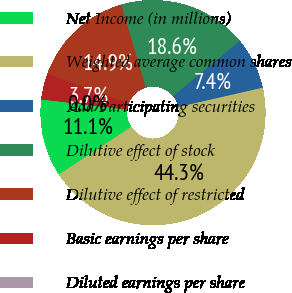<chart> <loc_0><loc_0><loc_500><loc_500><pie_chart><fcel>Net Income (in millions)<fcel>Weighted average common shares<fcel>Add Participating securities<fcel>Dilutive effect of stock<fcel>Dilutive effect of restricted<fcel>Basic earnings per share<fcel>Diluted earnings per share<nl><fcel>11.14%<fcel>44.31%<fcel>7.43%<fcel>18.56%<fcel>14.85%<fcel>3.71%<fcel>0.0%<nl></chart> 